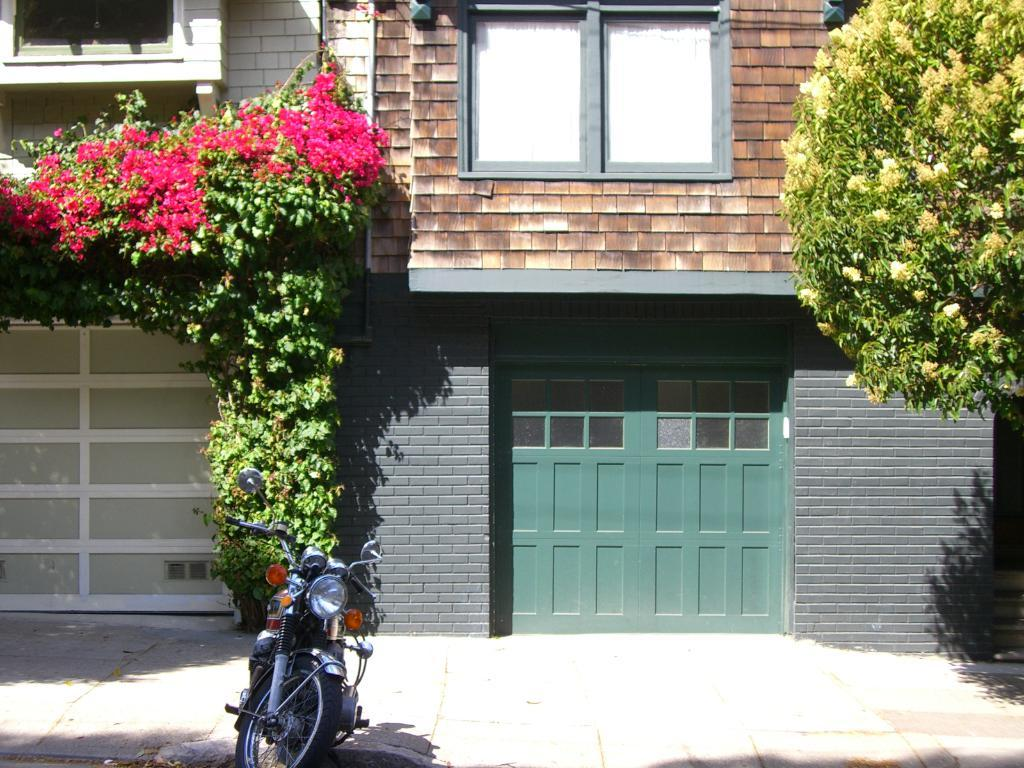What is the main subject of the image? There is a motorcycle in the image. What can be seen in the background of the image? There are plants, trees, flowers, and buildings in the background of the image. Can you describe the trees in the background? The trees have flowers growing on them. What type of environment might the image be depicting? The presence of trees, plants, and flowers suggests a natural or park-like setting, while the buildings indicate an urban or suburban area. What type of silk is being used to make the bells on the motorcycle in the image? There are no bells present on the motorcycle in the image, so it is not possible to determine the type of silk being used. 